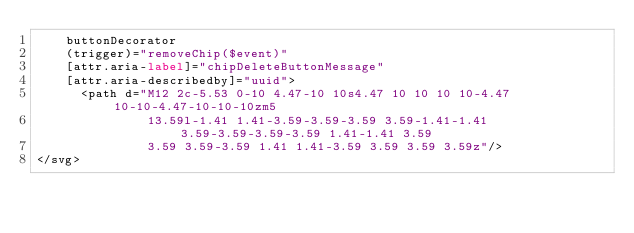Convert code to text. <code><loc_0><loc_0><loc_500><loc_500><_HTML_>    buttonDecorator
    (trigger)="removeChip($event)"
    [attr.aria-label]="chipDeleteButtonMessage"
    [attr.aria-describedby]="uuid">
      <path d="M12 2c-5.53 0-10 4.47-10 10s4.47 10 10 10 10-4.47 10-10-4.47-10-10-10zm5
               13.59l-1.41 1.41-3.59-3.59-3.59 3.59-1.41-1.41 3.59-3.59-3.59-3.59 1.41-1.41 3.59
               3.59 3.59-3.59 1.41 1.41-3.59 3.59 3.59 3.59z"/>
</svg>
</code> 